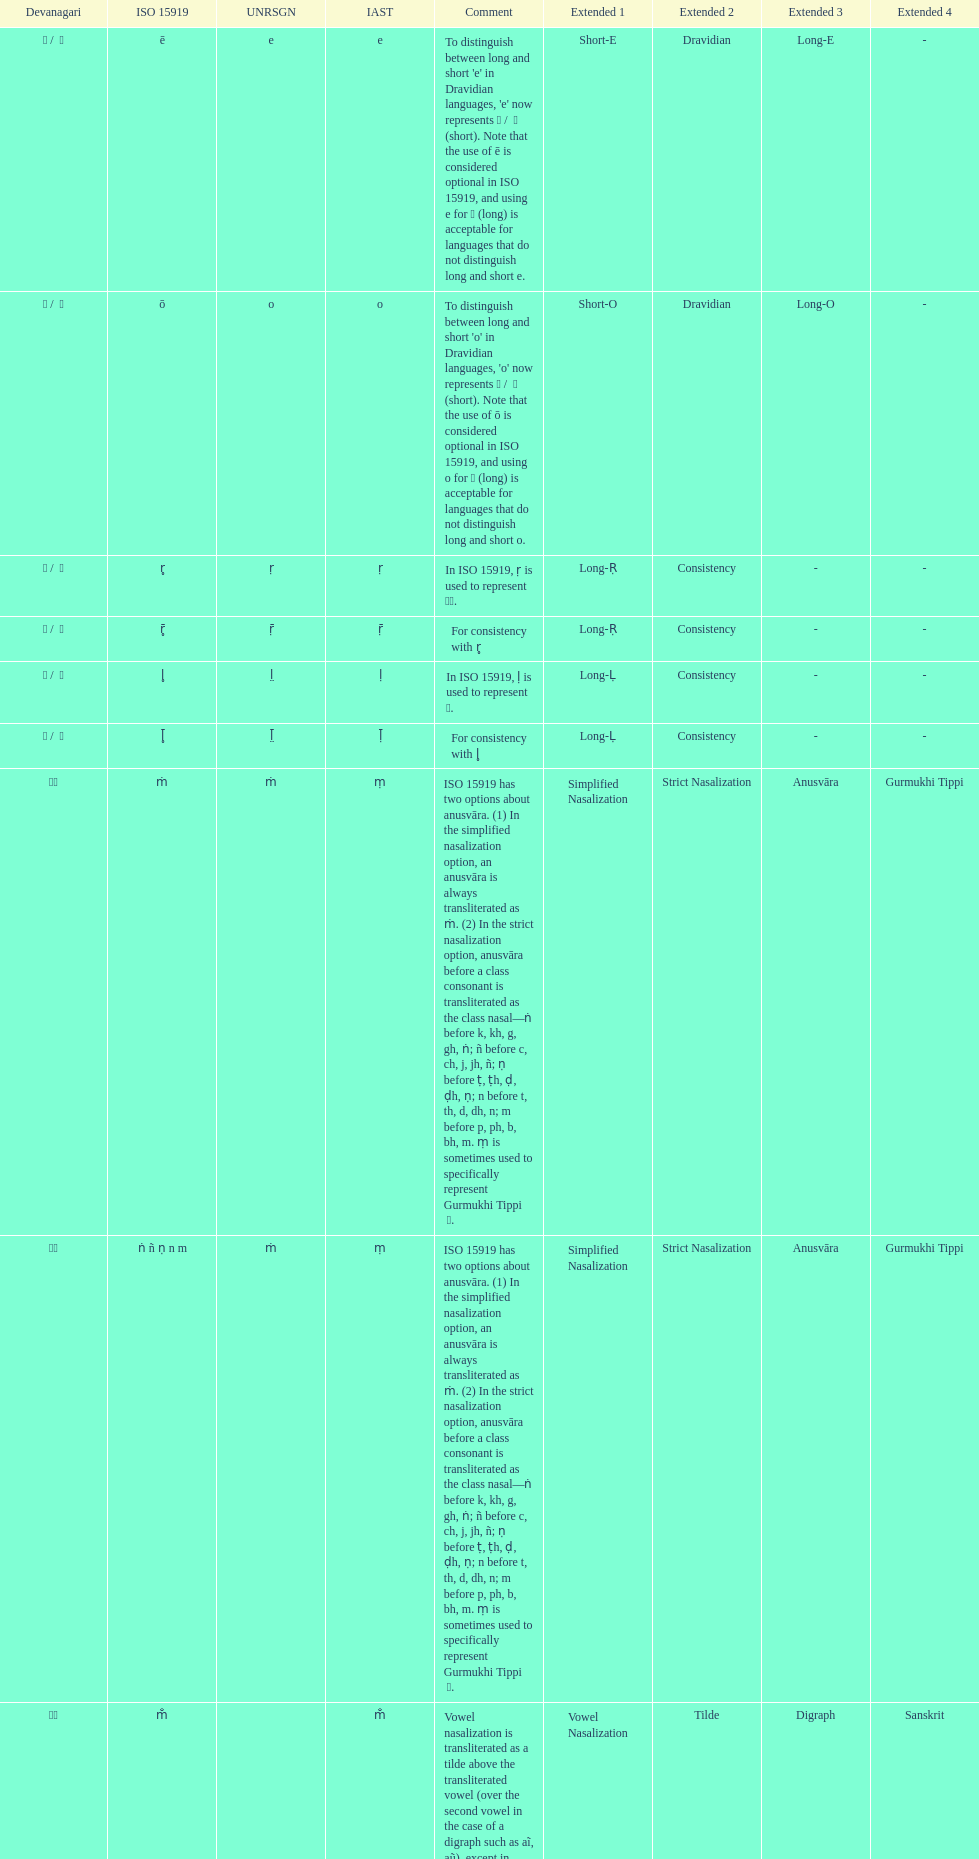What iast is listed before the o? E. 